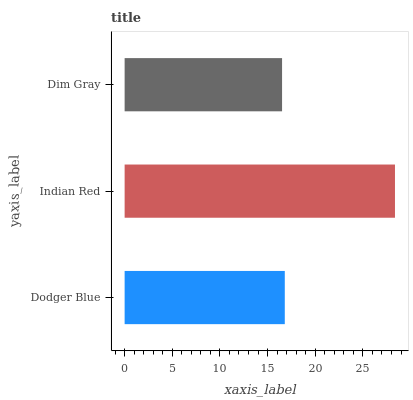Is Dim Gray the minimum?
Answer yes or no. Yes. Is Indian Red the maximum?
Answer yes or no. Yes. Is Indian Red the minimum?
Answer yes or no. No. Is Dim Gray the maximum?
Answer yes or no. No. Is Indian Red greater than Dim Gray?
Answer yes or no. Yes. Is Dim Gray less than Indian Red?
Answer yes or no. Yes. Is Dim Gray greater than Indian Red?
Answer yes or no. No. Is Indian Red less than Dim Gray?
Answer yes or no. No. Is Dodger Blue the high median?
Answer yes or no. Yes. Is Dodger Blue the low median?
Answer yes or no. Yes. Is Indian Red the high median?
Answer yes or no. No. Is Dim Gray the low median?
Answer yes or no. No. 